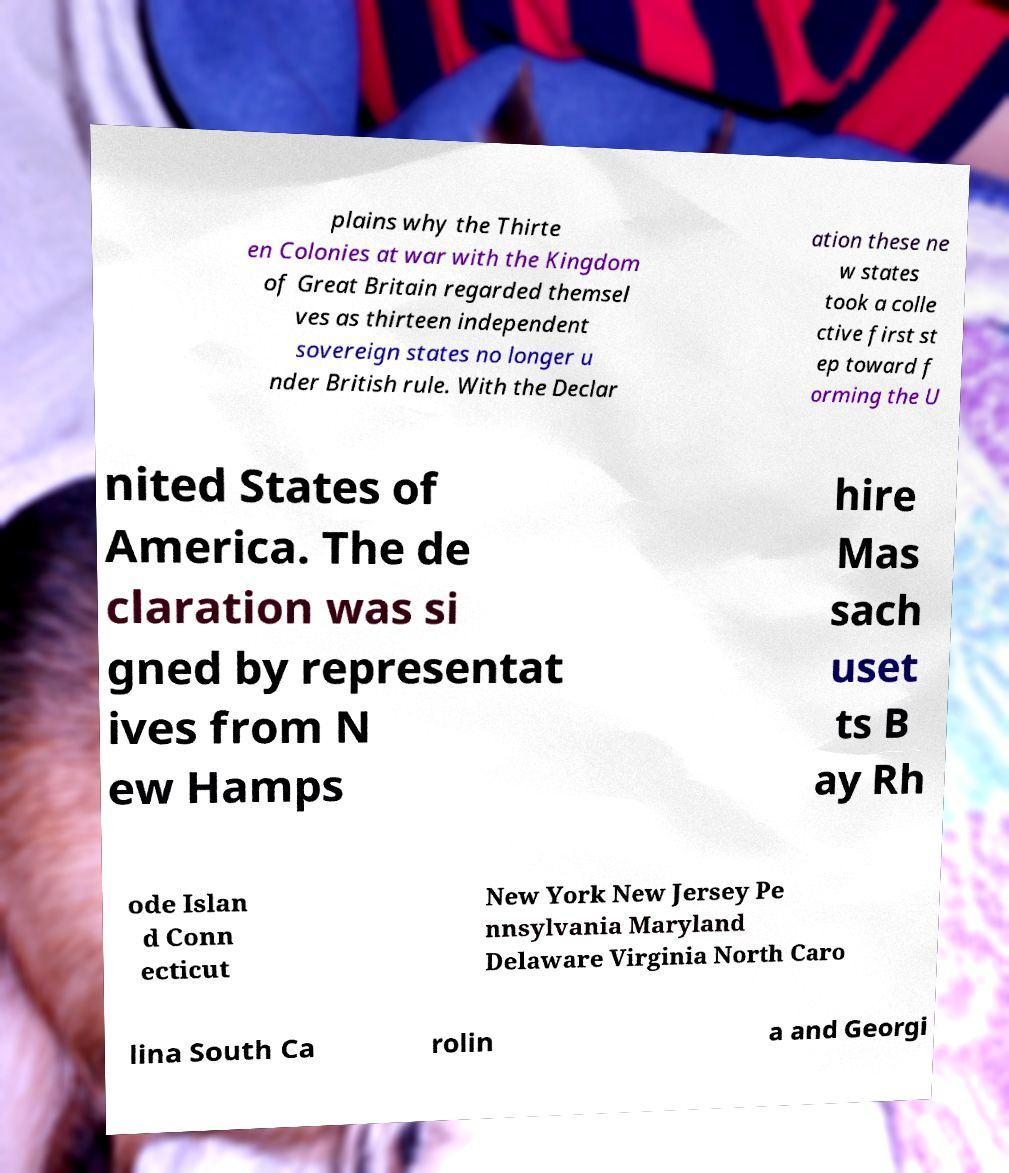Could you extract and type out the text from this image? plains why the Thirte en Colonies at war with the Kingdom of Great Britain regarded themsel ves as thirteen independent sovereign states no longer u nder British rule. With the Declar ation these ne w states took a colle ctive first st ep toward f orming the U nited States of America. The de claration was si gned by representat ives from N ew Hamps hire Mas sach uset ts B ay Rh ode Islan d Conn ecticut New York New Jersey Pe nnsylvania Maryland Delaware Virginia North Caro lina South Ca rolin a and Georgi 